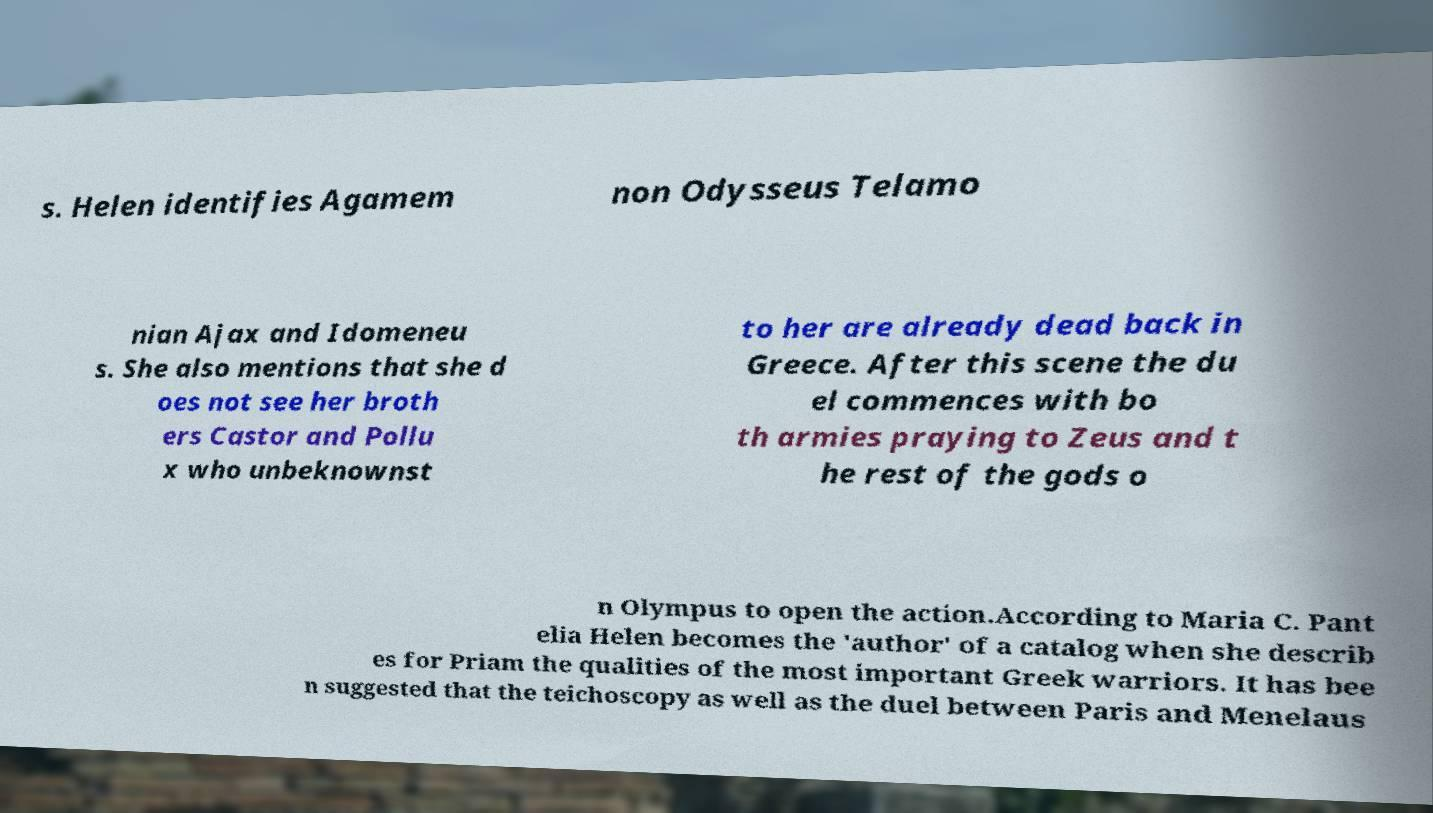For documentation purposes, I need the text within this image transcribed. Could you provide that? s. Helen identifies Agamem non Odysseus Telamo nian Ajax and Idomeneu s. She also mentions that she d oes not see her broth ers Castor and Pollu x who unbeknownst to her are already dead back in Greece. After this scene the du el commences with bo th armies praying to Zeus and t he rest of the gods o n Olympus to open the action.According to Maria C. Pant elia Helen becomes the 'author' of a catalog when she describ es for Priam the qualities of the most important Greek warriors. It has bee n suggested that the teichoscopy as well as the duel between Paris and Menelaus 